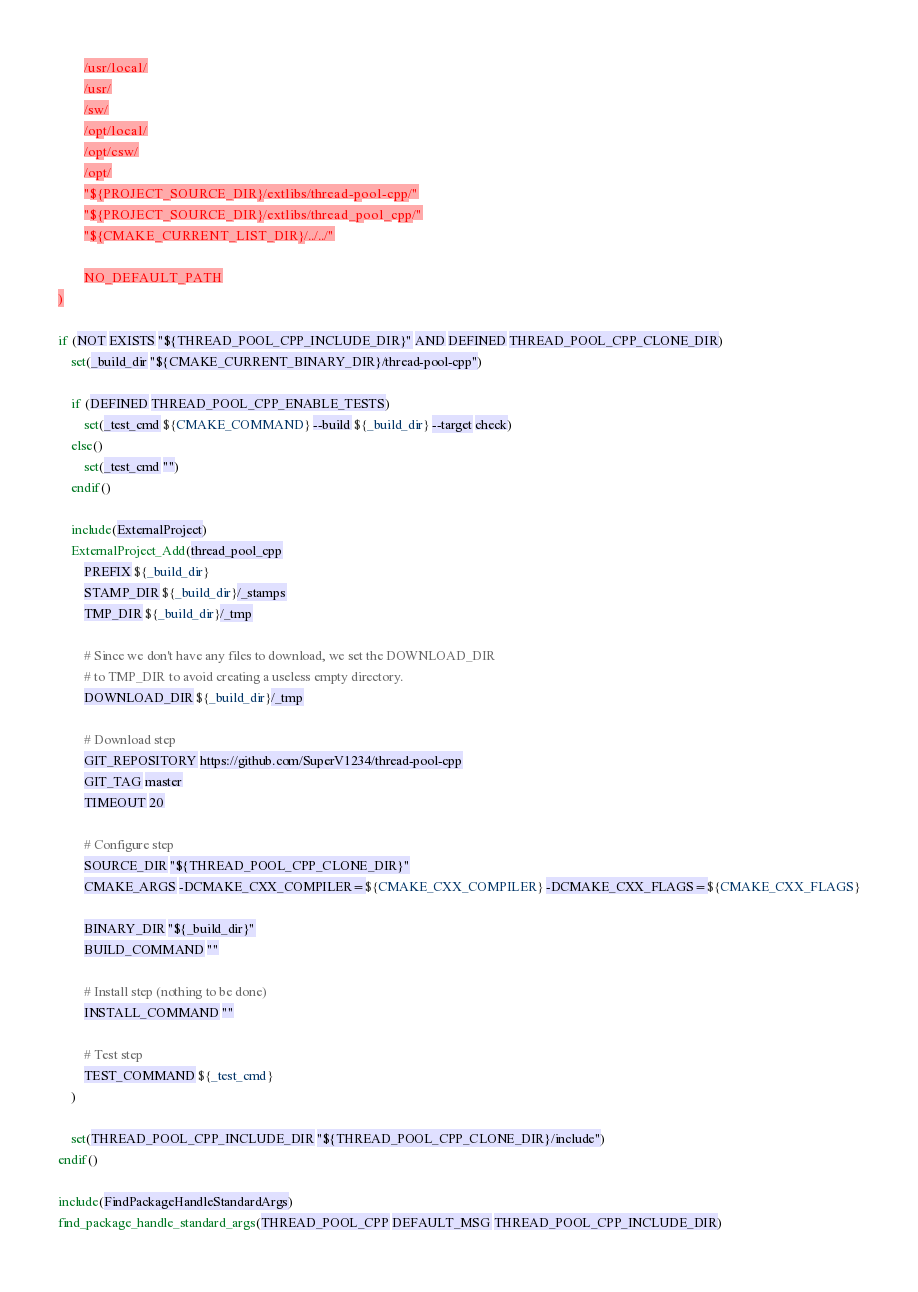<code> <loc_0><loc_0><loc_500><loc_500><_CMake_>        /usr/local/
        /usr/
        /sw/
        /opt/local/
        /opt/csw/
        /opt/
        "${PROJECT_SOURCE_DIR}/extlibs/thread-pool-cpp/"
        "${PROJECT_SOURCE_DIR}/extlibs/thread_pool_cpp/"
        "${CMAKE_CURRENT_LIST_DIR}/../../"

        NO_DEFAULT_PATH
)

if (NOT EXISTS "${THREAD_POOL_CPP_INCLUDE_DIR}" AND DEFINED THREAD_POOL_CPP_CLONE_DIR)
    set(_build_dir "${CMAKE_CURRENT_BINARY_DIR}/thread-pool-cpp")

    if (DEFINED THREAD_POOL_CPP_ENABLE_TESTS)
        set(_test_cmd ${CMAKE_COMMAND} --build ${_build_dir} --target check)
    else()
        set(_test_cmd "")
    endif()

    include(ExternalProject)
    ExternalProject_Add(thread_pool_cpp
        PREFIX ${_build_dir}
        STAMP_DIR ${_build_dir}/_stamps
        TMP_DIR ${_build_dir}/_tmp

        # Since we don't have any files to download, we set the DOWNLOAD_DIR
        # to TMP_DIR to avoid creating a useless empty directory.
        DOWNLOAD_DIR ${_build_dir}/_tmp

        # Download step
        GIT_REPOSITORY https://github.com/SuperV1234/thread-pool-cpp
        GIT_TAG master
        TIMEOUT 20

        # Configure step
        SOURCE_DIR "${THREAD_POOL_CPP_CLONE_DIR}"
        CMAKE_ARGS -DCMAKE_CXX_COMPILER=${CMAKE_CXX_COMPILER} -DCMAKE_CXX_FLAGS=${CMAKE_CXX_FLAGS}

        BINARY_DIR "${_build_dir}"
        BUILD_COMMAND ""

        # Install step (nothing to be done)
        INSTALL_COMMAND ""

        # Test step
        TEST_COMMAND ${_test_cmd}
    )

    set(THREAD_POOL_CPP_INCLUDE_DIR "${THREAD_POOL_CPP_CLONE_DIR}/include")
endif()

include(FindPackageHandleStandardArgs)
find_package_handle_standard_args(THREAD_POOL_CPP DEFAULT_MSG THREAD_POOL_CPP_INCLUDE_DIR)
</code> 